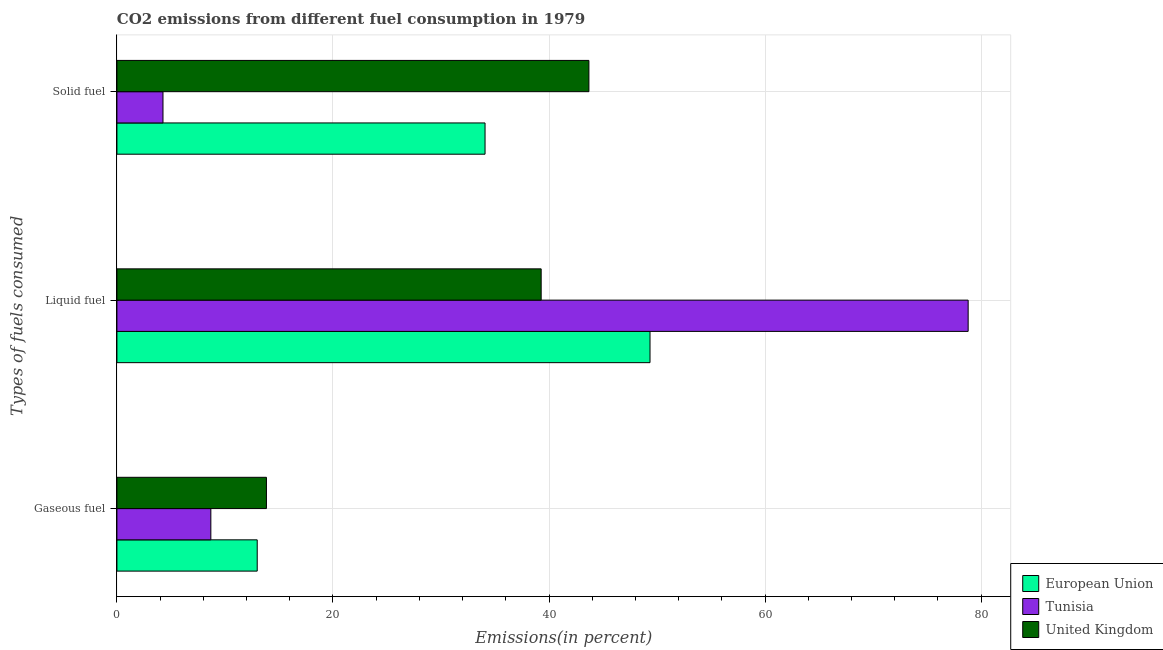How many different coloured bars are there?
Make the answer very short. 3. How many groups of bars are there?
Keep it short and to the point. 3. Are the number of bars on each tick of the Y-axis equal?
Ensure brevity in your answer.  Yes. What is the label of the 2nd group of bars from the top?
Provide a succinct answer. Liquid fuel. What is the percentage of liquid fuel emission in United Kingdom?
Ensure brevity in your answer.  39.28. Across all countries, what is the maximum percentage of liquid fuel emission?
Give a very brief answer. 78.8. Across all countries, what is the minimum percentage of liquid fuel emission?
Make the answer very short. 39.28. In which country was the percentage of solid fuel emission maximum?
Keep it short and to the point. United Kingdom. In which country was the percentage of solid fuel emission minimum?
Provide a short and direct response. Tunisia. What is the total percentage of gaseous fuel emission in the graph?
Make the answer very short. 35.53. What is the difference between the percentage of gaseous fuel emission in United Kingdom and that in Tunisia?
Keep it short and to the point. 5.15. What is the difference between the percentage of liquid fuel emission in European Union and the percentage of gaseous fuel emission in Tunisia?
Offer a very short reply. 40.66. What is the average percentage of solid fuel emission per country?
Provide a short and direct response. 27.35. What is the difference between the percentage of gaseous fuel emission and percentage of liquid fuel emission in European Union?
Ensure brevity in your answer.  -36.36. In how many countries, is the percentage of liquid fuel emission greater than 36 %?
Offer a very short reply. 3. What is the ratio of the percentage of liquid fuel emission in United Kingdom to that in Tunisia?
Provide a succinct answer. 0.5. Is the difference between the percentage of solid fuel emission in Tunisia and United Kingdom greater than the difference between the percentage of liquid fuel emission in Tunisia and United Kingdom?
Your answer should be very brief. No. What is the difference between the highest and the second highest percentage of gaseous fuel emission?
Your answer should be very brief. 0.85. What is the difference between the highest and the lowest percentage of gaseous fuel emission?
Ensure brevity in your answer.  5.15. Is the sum of the percentage of liquid fuel emission in United Kingdom and Tunisia greater than the maximum percentage of solid fuel emission across all countries?
Your answer should be very brief. Yes. What does the 2nd bar from the top in Liquid fuel represents?
Ensure brevity in your answer.  Tunisia. Does the graph contain grids?
Your response must be concise. Yes. Where does the legend appear in the graph?
Offer a terse response. Bottom right. How are the legend labels stacked?
Give a very brief answer. Vertical. What is the title of the graph?
Your response must be concise. CO2 emissions from different fuel consumption in 1979. What is the label or title of the X-axis?
Ensure brevity in your answer.  Emissions(in percent). What is the label or title of the Y-axis?
Make the answer very short. Types of fuels consumed. What is the Emissions(in percent) of European Union in Gaseous fuel?
Your answer should be very brief. 12.99. What is the Emissions(in percent) of Tunisia in Gaseous fuel?
Ensure brevity in your answer.  8.7. What is the Emissions(in percent) of United Kingdom in Gaseous fuel?
Your answer should be very brief. 13.84. What is the Emissions(in percent) in European Union in Liquid fuel?
Ensure brevity in your answer.  49.35. What is the Emissions(in percent) of Tunisia in Liquid fuel?
Make the answer very short. 78.8. What is the Emissions(in percent) in United Kingdom in Liquid fuel?
Provide a succinct answer. 39.28. What is the Emissions(in percent) in European Union in Solid fuel?
Offer a very short reply. 34.08. What is the Emissions(in percent) in Tunisia in Solid fuel?
Your answer should be compact. 4.26. What is the Emissions(in percent) in United Kingdom in Solid fuel?
Your answer should be compact. 43.7. Across all Types of fuels consumed, what is the maximum Emissions(in percent) of European Union?
Make the answer very short. 49.35. Across all Types of fuels consumed, what is the maximum Emissions(in percent) in Tunisia?
Keep it short and to the point. 78.8. Across all Types of fuels consumed, what is the maximum Emissions(in percent) of United Kingdom?
Offer a terse response. 43.7. Across all Types of fuels consumed, what is the minimum Emissions(in percent) in European Union?
Offer a very short reply. 12.99. Across all Types of fuels consumed, what is the minimum Emissions(in percent) of Tunisia?
Keep it short and to the point. 4.26. Across all Types of fuels consumed, what is the minimum Emissions(in percent) of United Kingdom?
Your response must be concise. 13.84. What is the total Emissions(in percent) in European Union in the graph?
Offer a very short reply. 96.42. What is the total Emissions(in percent) in Tunisia in the graph?
Your answer should be compact. 91.76. What is the total Emissions(in percent) of United Kingdom in the graph?
Your answer should be very brief. 96.81. What is the difference between the Emissions(in percent) in European Union in Gaseous fuel and that in Liquid fuel?
Ensure brevity in your answer.  -36.36. What is the difference between the Emissions(in percent) in Tunisia in Gaseous fuel and that in Liquid fuel?
Offer a very short reply. -70.11. What is the difference between the Emissions(in percent) of United Kingdom in Gaseous fuel and that in Liquid fuel?
Ensure brevity in your answer.  -25.43. What is the difference between the Emissions(in percent) in European Union in Gaseous fuel and that in Solid fuel?
Make the answer very short. -21.09. What is the difference between the Emissions(in percent) in Tunisia in Gaseous fuel and that in Solid fuel?
Your response must be concise. 4.43. What is the difference between the Emissions(in percent) in United Kingdom in Gaseous fuel and that in Solid fuel?
Provide a short and direct response. -29.85. What is the difference between the Emissions(in percent) in European Union in Liquid fuel and that in Solid fuel?
Your response must be concise. 15.27. What is the difference between the Emissions(in percent) in Tunisia in Liquid fuel and that in Solid fuel?
Give a very brief answer. 74.54. What is the difference between the Emissions(in percent) in United Kingdom in Liquid fuel and that in Solid fuel?
Provide a short and direct response. -4.42. What is the difference between the Emissions(in percent) in European Union in Gaseous fuel and the Emissions(in percent) in Tunisia in Liquid fuel?
Your answer should be compact. -65.82. What is the difference between the Emissions(in percent) of European Union in Gaseous fuel and the Emissions(in percent) of United Kingdom in Liquid fuel?
Offer a very short reply. -26.29. What is the difference between the Emissions(in percent) of Tunisia in Gaseous fuel and the Emissions(in percent) of United Kingdom in Liquid fuel?
Keep it short and to the point. -30.58. What is the difference between the Emissions(in percent) of European Union in Gaseous fuel and the Emissions(in percent) of Tunisia in Solid fuel?
Ensure brevity in your answer.  8.72. What is the difference between the Emissions(in percent) in European Union in Gaseous fuel and the Emissions(in percent) in United Kingdom in Solid fuel?
Give a very brief answer. -30.71. What is the difference between the Emissions(in percent) of Tunisia in Gaseous fuel and the Emissions(in percent) of United Kingdom in Solid fuel?
Offer a terse response. -35. What is the difference between the Emissions(in percent) of European Union in Liquid fuel and the Emissions(in percent) of Tunisia in Solid fuel?
Keep it short and to the point. 45.09. What is the difference between the Emissions(in percent) in European Union in Liquid fuel and the Emissions(in percent) in United Kingdom in Solid fuel?
Provide a succinct answer. 5.66. What is the difference between the Emissions(in percent) of Tunisia in Liquid fuel and the Emissions(in percent) of United Kingdom in Solid fuel?
Provide a short and direct response. 35.11. What is the average Emissions(in percent) of European Union per Types of fuels consumed?
Provide a succinct answer. 32.14. What is the average Emissions(in percent) in Tunisia per Types of fuels consumed?
Your answer should be very brief. 30.59. What is the average Emissions(in percent) of United Kingdom per Types of fuels consumed?
Give a very brief answer. 32.27. What is the difference between the Emissions(in percent) in European Union and Emissions(in percent) in Tunisia in Gaseous fuel?
Give a very brief answer. 4.29. What is the difference between the Emissions(in percent) in European Union and Emissions(in percent) in United Kingdom in Gaseous fuel?
Make the answer very short. -0.85. What is the difference between the Emissions(in percent) in Tunisia and Emissions(in percent) in United Kingdom in Gaseous fuel?
Give a very brief answer. -5.15. What is the difference between the Emissions(in percent) of European Union and Emissions(in percent) of Tunisia in Liquid fuel?
Provide a short and direct response. -29.45. What is the difference between the Emissions(in percent) in European Union and Emissions(in percent) in United Kingdom in Liquid fuel?
Your response must be concise. 10.08. What is the difference between the Emissions(in percent) of Tunisia and Emissions(in percent) of United Kingdom in Liquid fuel?
Ensure brevity in your answer.  39.53. What is the difference between the Emissions(in percent) of European Union and Emissions(in percent) of Tunisia in Solid fuel?
Keep it short and to the point. 29.82. What is the difference between the Emissions(in percent) of European Union and Emissions(in percent) of United Kingdom in Solid fuel?
Your answer should be compact. -9.62. What is the difference between the Emissions(in percent) in Tunisia and Emissions(in percent) in United Kingdom in Solid fuel?
Your answer should be compact. -39.43. What is the ratio of the Emissions(in percent) of European Union in Gaseous fuel to that in Liquid fuel?
Give a very brief answer. 0.26. What is the ratio of the Emissions(in percent) of Tunisia in Gaseous fuel to that in Liquid fuel?
Offer a terse response. 0.11. What is the ratio of the Emissions(in percent) in United Kingdom in Gaseous fuel to that in Liquid fuel?
Your answer should be compact. 0.35. What is the ratio of the Emissions(in percent) in European Union in Gaseous fuel to that in Solid fuel?
Your answer should be very brief. 0.38. What is the ratio of the Emissions(in percent) in Tunisia in Gaseous fuel to that in Solid fuel?
Offer a very short reply. 2.04. What is the ratio of the Emissions(in percent) of United Kingdom in Gaseous fuel to that in Solid fuel?
Offer a very short reply. 0.32. What is the ratio of the Emissions(in percent) of European Union in Liquid fuel to that in Solid fuel?
Keep it short and to the point. 1.45. What is the ratio of the Emissions(in percent) of Tunisia in Liquid fuel to that in Solid fuel?
Keep it short and to the point. 18.48. What is the ratio of the Emissions(in percent) of United Kingdom in Liquid fuel to that in Solid fuel?
Offer a very short reply. 0.9. What is the difference between the highest and the second highest Emissions(in percent) of European Union?
Offer a very short reply. 15.27. What is the difference between the highest and the second highest Emissions(in percent) of Tunisia?
Ensure brevity in your answer.  70.11. What is the difference between the highest and the second highest Emissions(in percent) of United Kingdom?
Give a very brief answer. 4.42. What is the difference between the highest and the lowest Emissions(in percent) of European Union?
Your answer should be compact. 36.36. What is the difference between the highest and the lowest Emissions(in percent) of Tunisia?
Offer a terse response. 74.54. What is the difference between the highest and the lowest Emissions(in percent) in United Kingdom?
Keep it short and to the point. 29.85. 